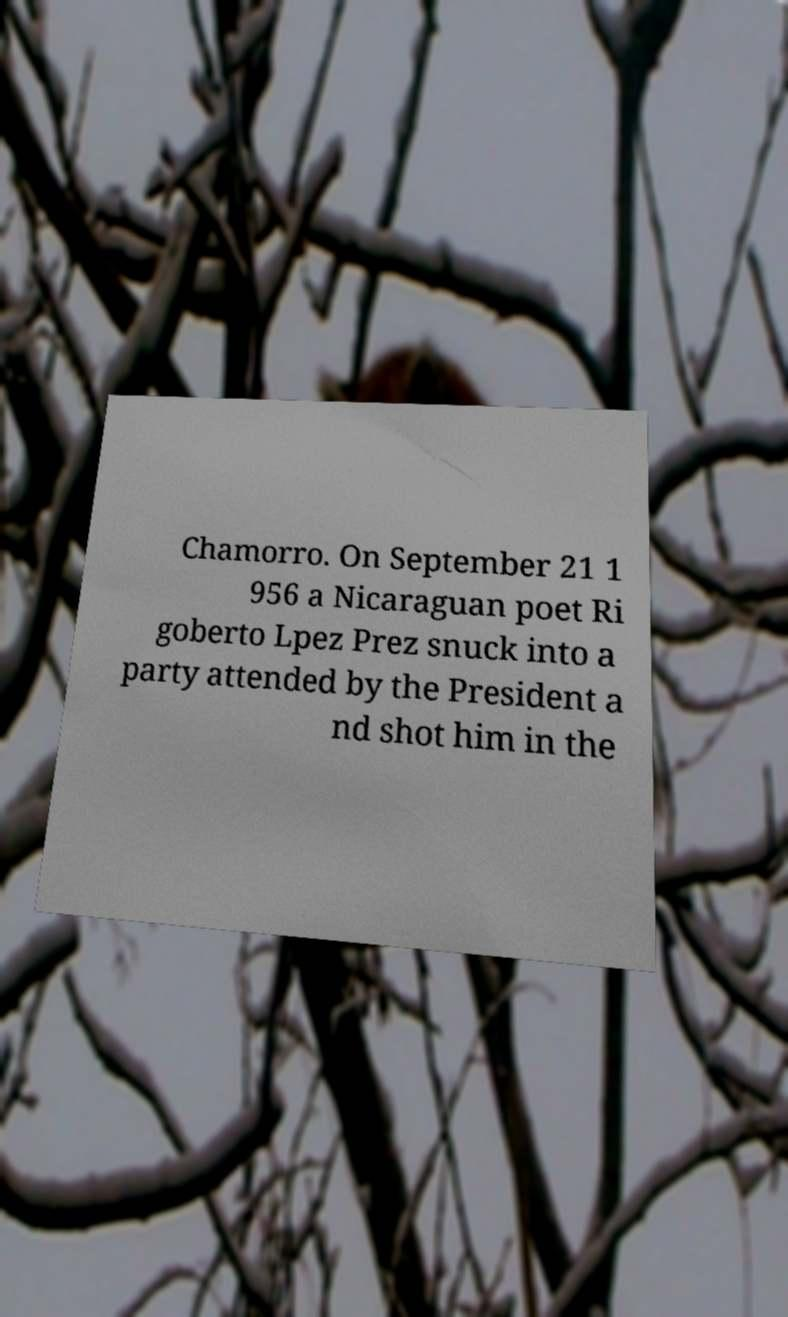There's text embedded in this image that I need extracted. Can you transcribe it verbatim? Chamorro. On September 21 1 956 a Nicaraguan poet Ri goberto Lpez Prez snuck into a party attended by the President a nd shot him in the 